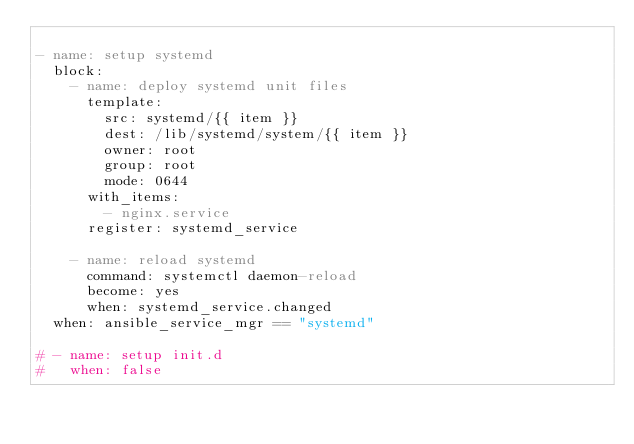<code> <loc_0><loc_0><loc_500><loc_500><_YAML_>
- name: setup systemd
  block:
    - name: deploy systemd unit files
      template:
        src: systemd/{{ item }}
        dest: /lib/systemd/system/{{ item }}
        owner: root
        group: root
        mode: 0644
      with_items:
        - nginx.service
      register: systemd_service

    - name: reload systemd
      command: systemctl daemon-reload
      become: yes
      when: systemd_service.changed
  when: ansible_service_mgr == "systemd"

# - name: setup init.d
#   when: false
</code> 